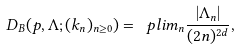<formula> <loc_0><loc_0><loc_500><loc_500>D _ { B } ( p , \Lambda ; ( k _ { n } ) _ { n \geq 0 } ) = \ p l i m _ { n } \frac { | \Lambda _ { n } | } { ( 2 n ) ^ { 2 d } } ,</formula> 